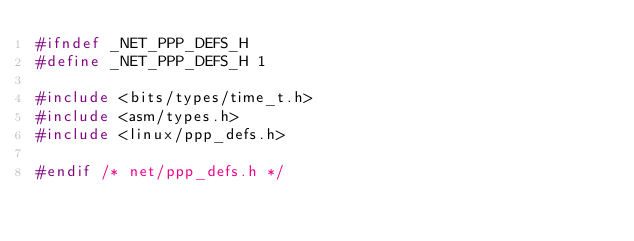Convert code to text. <code><loc_0><loc_0><loc_500><loc_500><_C_>#ifndef _NET_PPP_DEFS_H
#define _NET_PPP_DEFS_H 1

#include <bits/types/time_t.h>
#include <asm/types.h>
#include <linux/ppp_defs.h>

#endif /* net/ppp_defs.h */</code> 